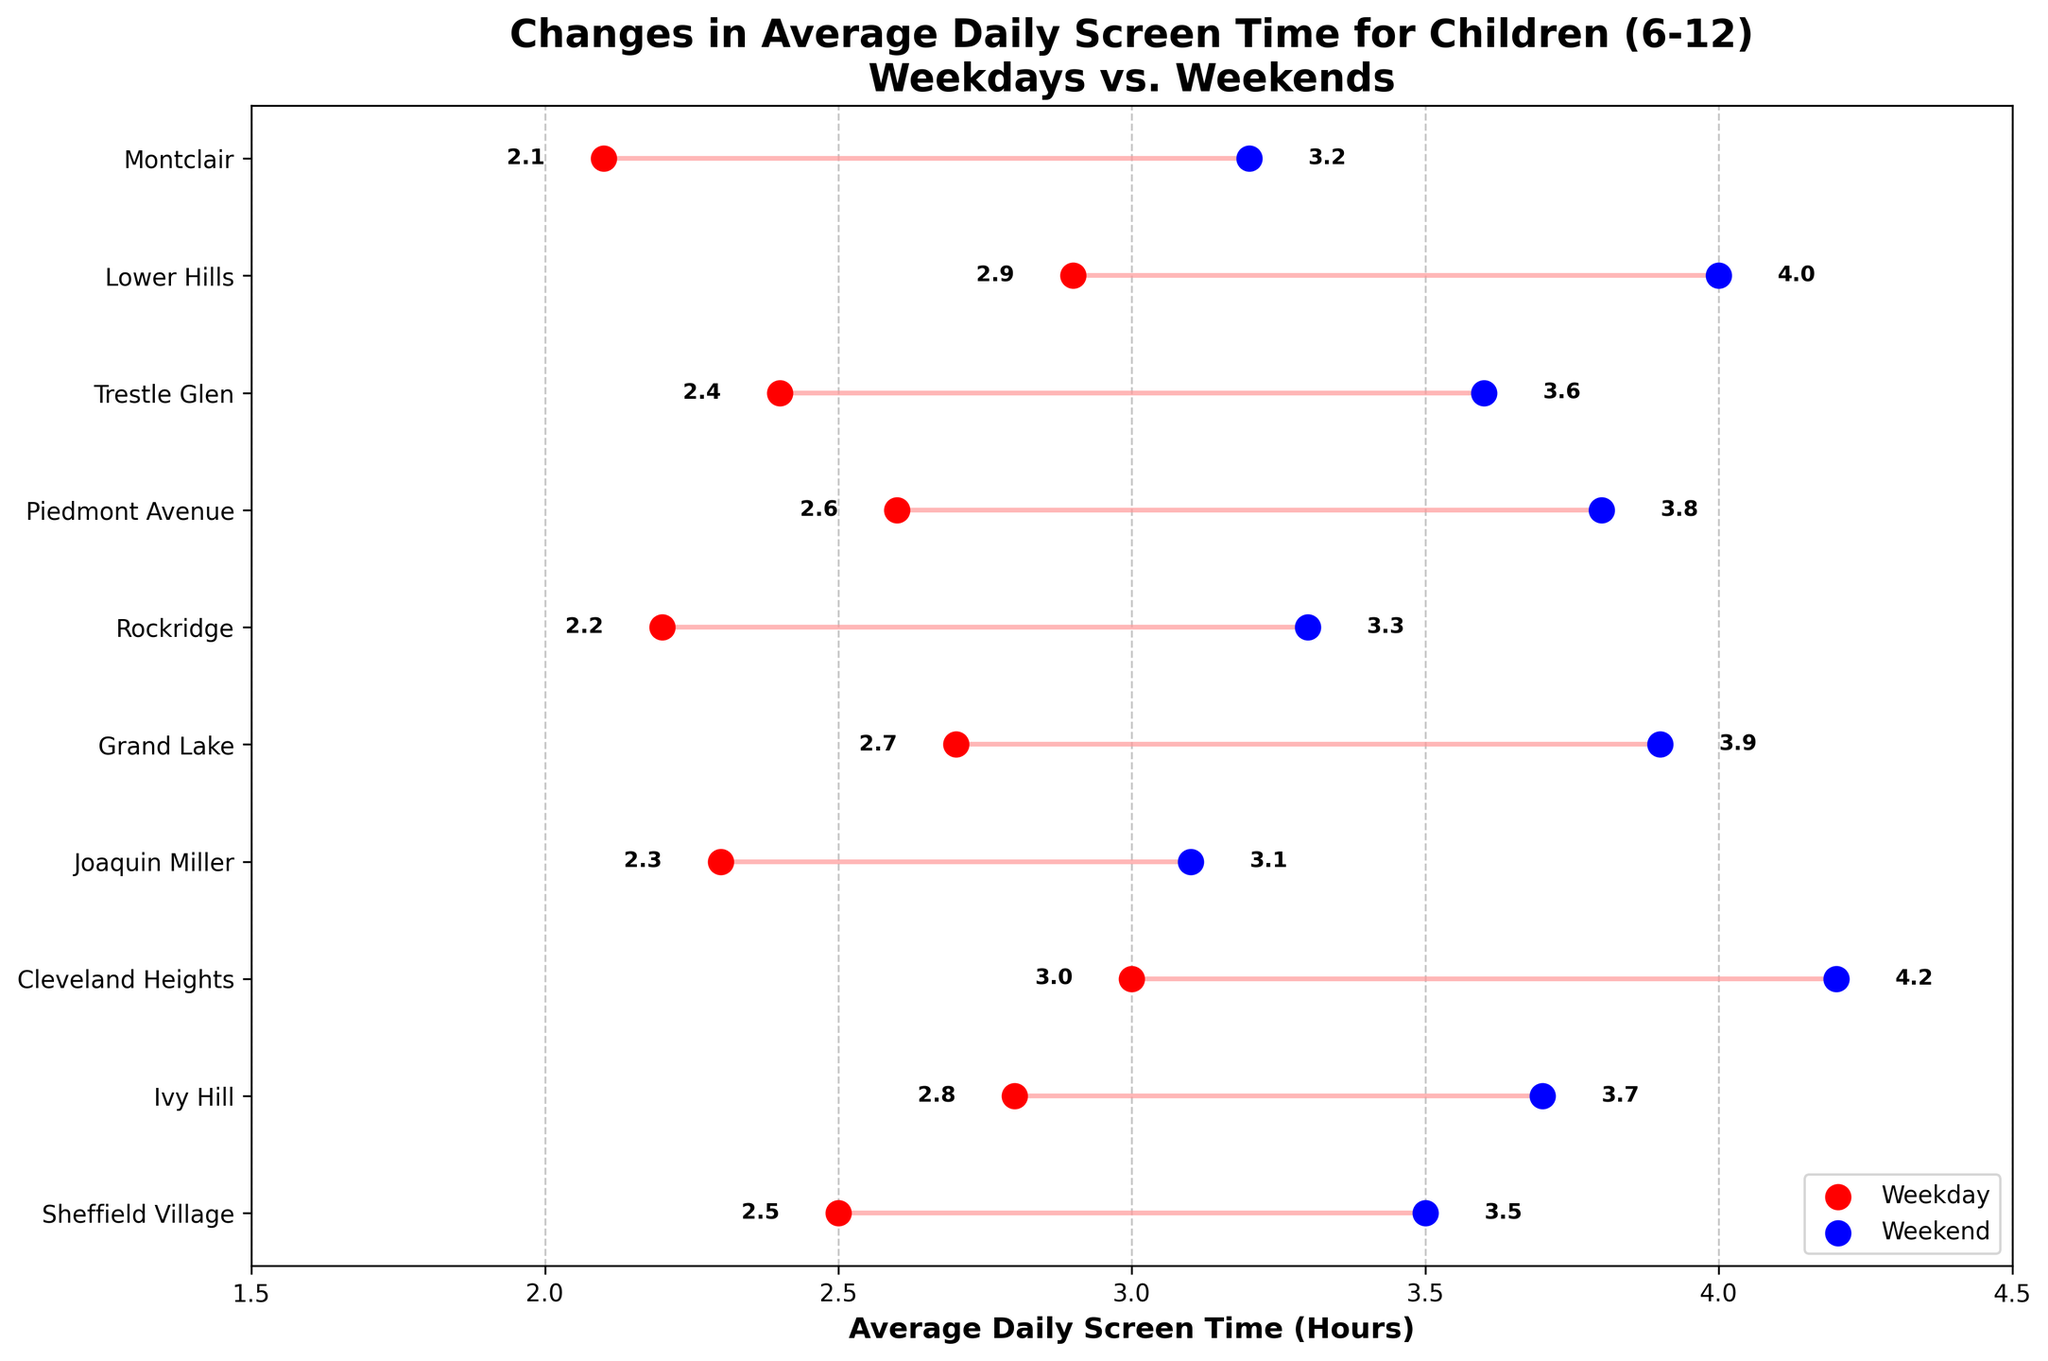How many neighborhoods are shown in the plot? To find the number of neighborhoods, count the tick labels on the y-axis. There are 10 neighborhoods listed.
Answer: 10 Which neighborhood has the highest average weekend screen time? Identify the highest weekend screen time by looking at the rightmost blue dots. Cleveland Heights has the highest value at 4.2 hours.
Answer: Cleveland Heights Which neighborhood shows the smallest difference in screen time between weekdays and weekends? To find the smallest difference, look at the length of the lines connecting the red and blue dots for each neighborhood. Montclair shows the smallest difference, at 1.1 hours (3.2 - 2.1).
Answer: Montclair What is the average weekday screen time across all neighborhoods? Sum the weekday screen times (2.5 + 2.8 + 3.0 + 2.3 + 2.7 + 2.2 + 2.6 + 2.4 + 2.9 + 2.1) and divide by the number of neighborhoods (10). (2.5 + 2.8 + 3.0 + 2.3 + 2.7 + 2.2 + 2.6 + 2.4 + 2.9 + 2.1) / 10 = 25.5 / 10 = 2.55 hours.
Answer: 2.55 How much more screen time on average do children in Lower Hills have on weekends compared to weekdays? Find Lower Hills on the y-axis, and subtract the weekday value from the weekend value. 4.0 - 2.9 = 1.1 hours.
Answer: 1.1 Which neighborhood has the lowest weekday screen time, and what is the value? Identify the lowest weekday screen time by looking at the leftmost red dots. Montclair has the lowest value at 2.1 hours.
Answer: Montclair, 2.1 hours What is the range of screen time differences between weekdays and weekends across all neighborhoods? Compute the differences for each neighborhood and find the range (largest difference - smallest difference). Differences: [1.0, 0.9, 1.2, 0.8, 1.2, 1.1, 1.2, 1.2, 1.1, 1.1]. Range = 1.2 (max) - 0.8 (min) = 0.4 hours.
Answer: 0.4 How does screen time in Rockridge compare between weekdays and weekends? Locate Rockridge on the y-axis and compare the red dot (weekday) and blue dot (weekend). Weekday is 2.2 hours, weekend is 3.3 hours, showing an increase of 1.1 hours.
Answer: Increase by 1.1 hours 